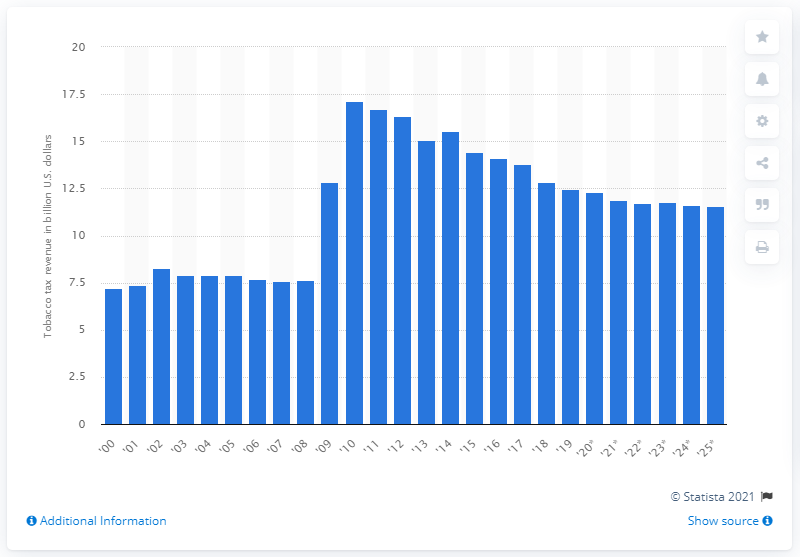Point out several critical features in this image. In 2019, the total revenue generated from tobacco taxes in the United States was 12.46 billion dollars. The anticipated decrease in tobacco tax revenues in 2025 is expected to be 11.55. 